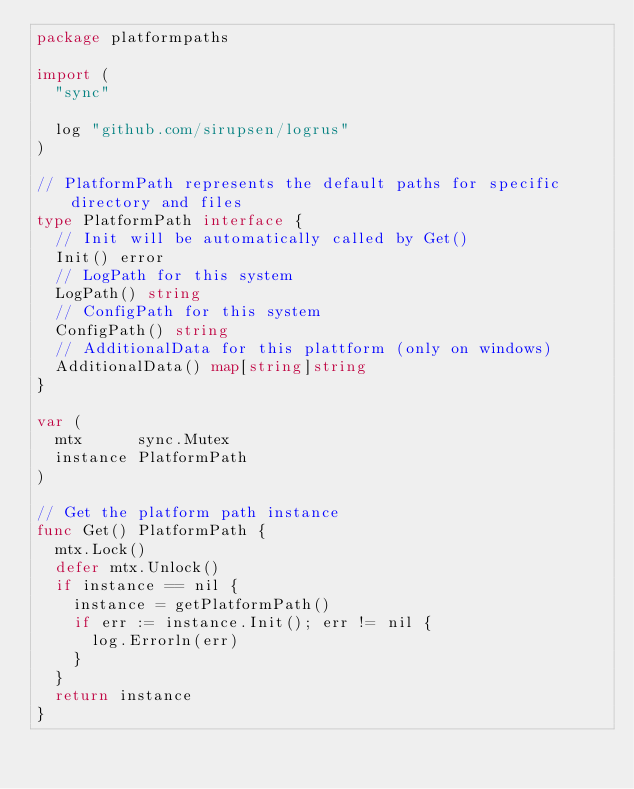Convert code to text. <code><loc_0><loc_0><loc_500><loc_500><_Go_>package platformpaths

import (
	"sync"

	log "github.com/sirupsen/logrus"
)

// PlatformPath represents the default paths for specific directory and files
type PlatformPath interface {
	// Init will be automatically called by Get()
	Init() error
	// LogPath for this system
	LogPath() string
	// ConfigPath for this system
	ConfigPath() string
	// AdditionalData for this plattform (only on windows)
	AdditionalData() map[string]string
}

var (
	mtx      sync.Mutex
	instance PlatformPath
)

// Get the platform path instance
func Get() PlatformPath {
	mtx.Lock()
	defer mtx.Unlock()
	if instance == nil {
		instance = getPlatformPath()
		if err := instance.Init(); err != nil {
			log.Errorln(err)
		}
	}
	return instance
}
</code> 